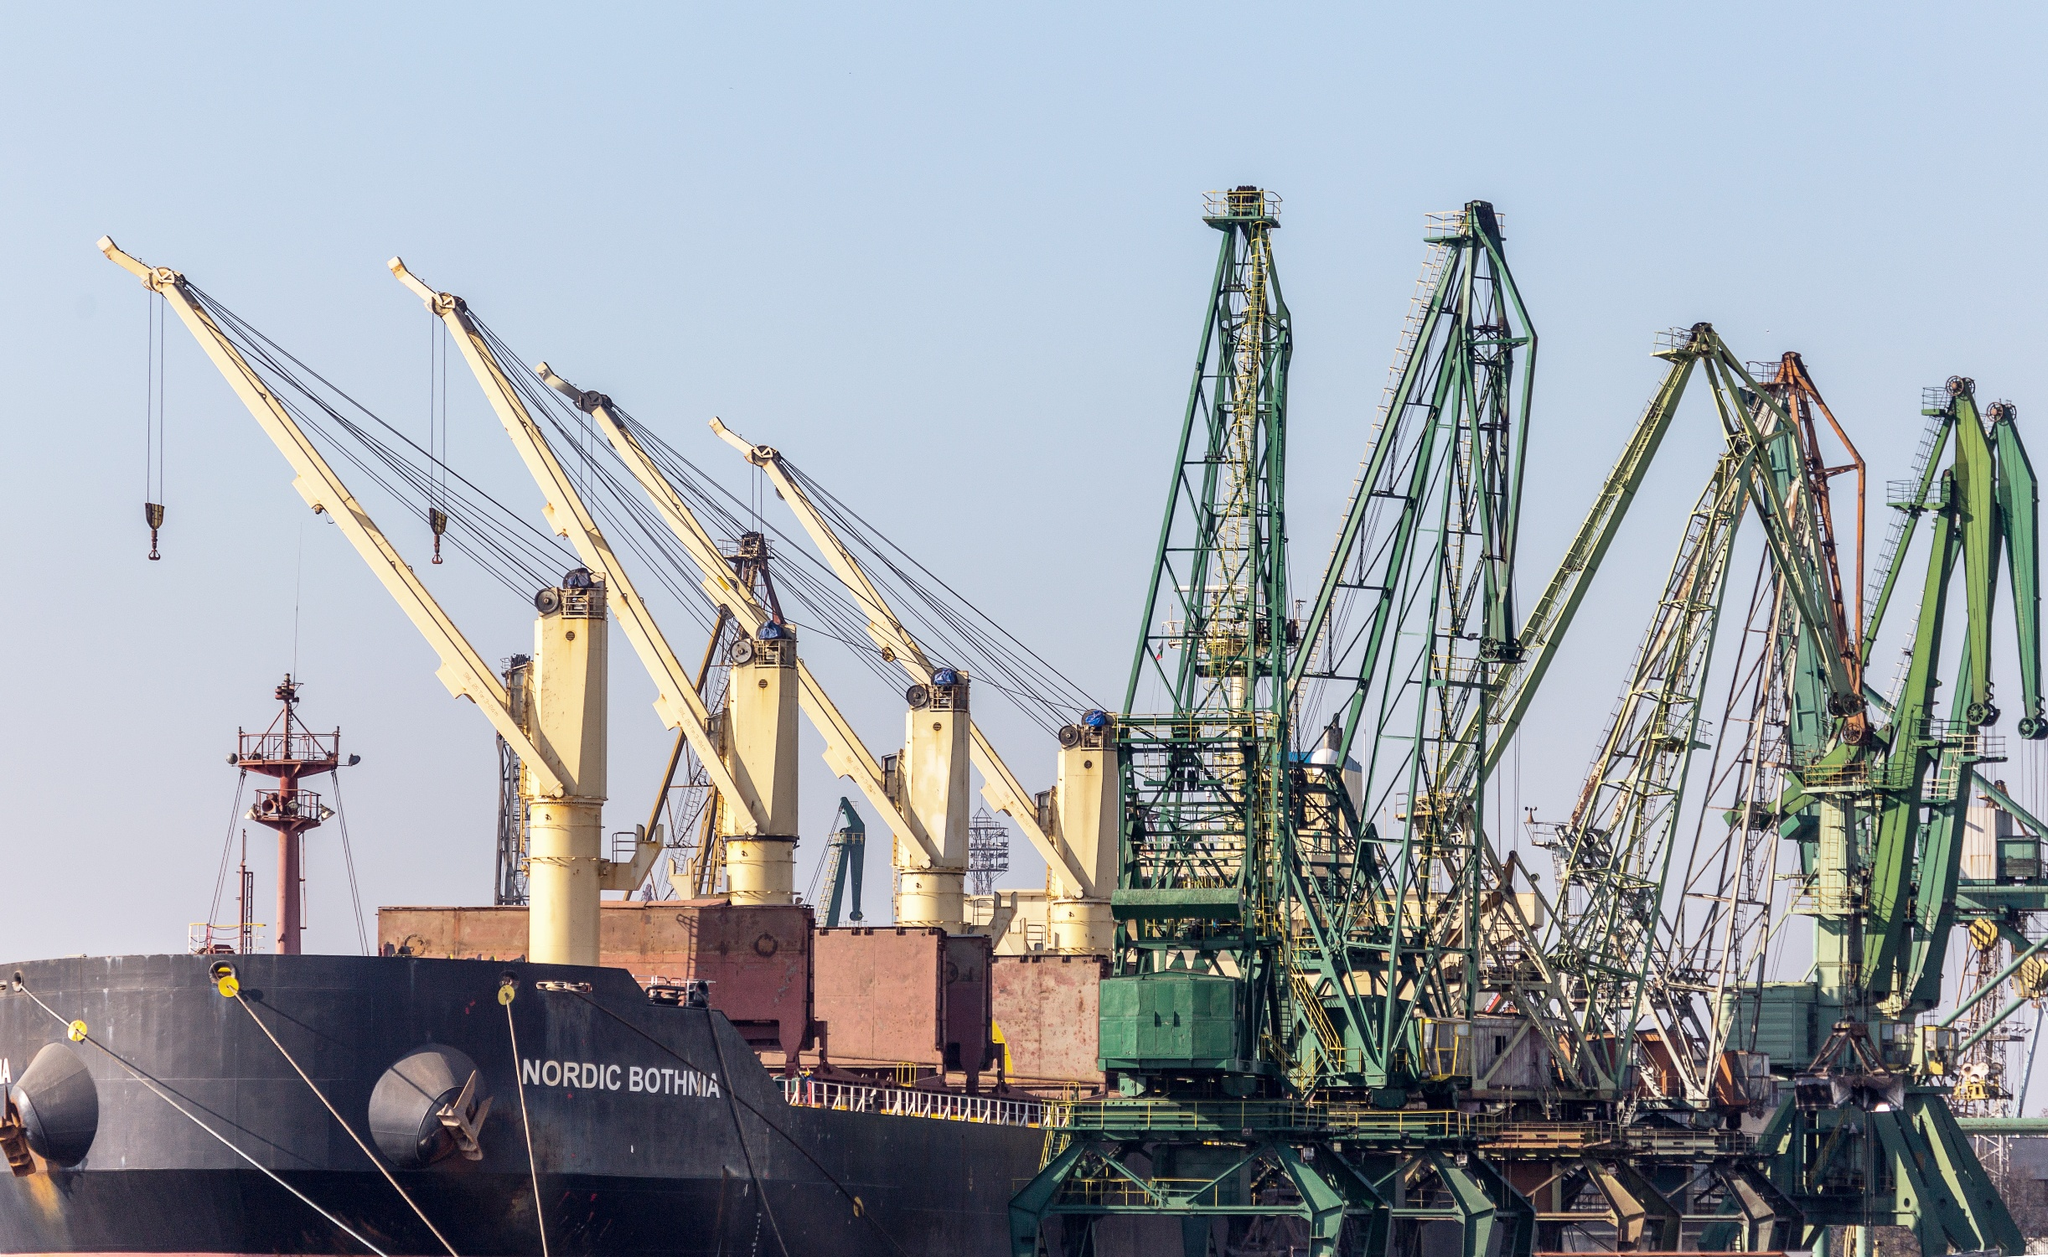What is this photo about? The photo captures a detailed scene of maritime logistics at a busy port. It prominently features the 'Nordic Bothnia', a large cargo ship, painted in bold black, moored at the dock. The ship is flanked by multiple heavy-duty cranes, painted in stark white, ready to load or unload cargo, illustrating the dynamic exchange of goods. The surrounding area is bustling with activity, highlighted by numerous green cranes and scattered industrial equipment. This setting is a testament to the complex, large-scale operations crucial for global trade, offering a glimpse into the intricate and coordinated efforts required in modern maritime shipping. 